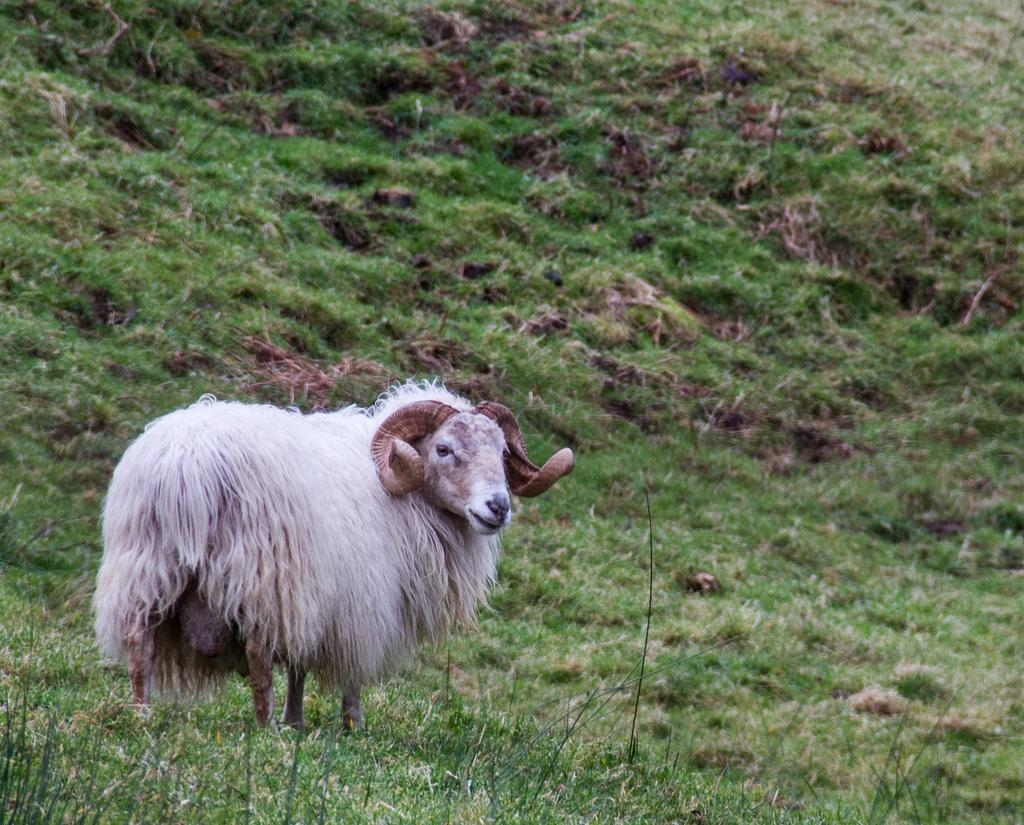What type of animal is in the image? The animal in the image has white and brown coloring. Can you describe the animal's position in the image? The animal is on the ground. What can be seen in the background of the image? There is grass visible in the background of the image. What is the animal's tendency to chew on copper objects in the image? There is no indication of the animal's tendency to chew on copper objects in the image. 